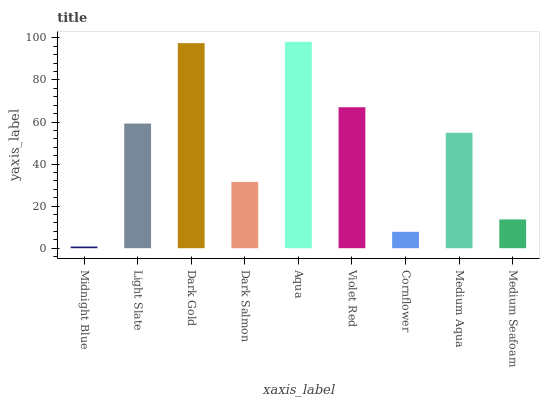Is Light Slate the minimum?
Answer yes or no. No. Is Light Slate the maximum?
Answer yes or no. No. Is Light Slate greater than Midnight Blue?
Answer yes or no. Yes. Is Midnight Blue less than Light Slate?
Answer yes or no. Yes. Is Midnight Blue greater than Light Slate?
Answer yes or no. No. Is Light Slate less than Midnight Blue?
Answer yes or no. No. Is Medium Aqua the high median?
Answer yes or no. Yes. Is Medium Aqua the low median?
Answer yes or no. Yes. Is Light Slate the high median?
Answer yes or no. No. Is Cornflower the low median?
Answer yes or no. No. 